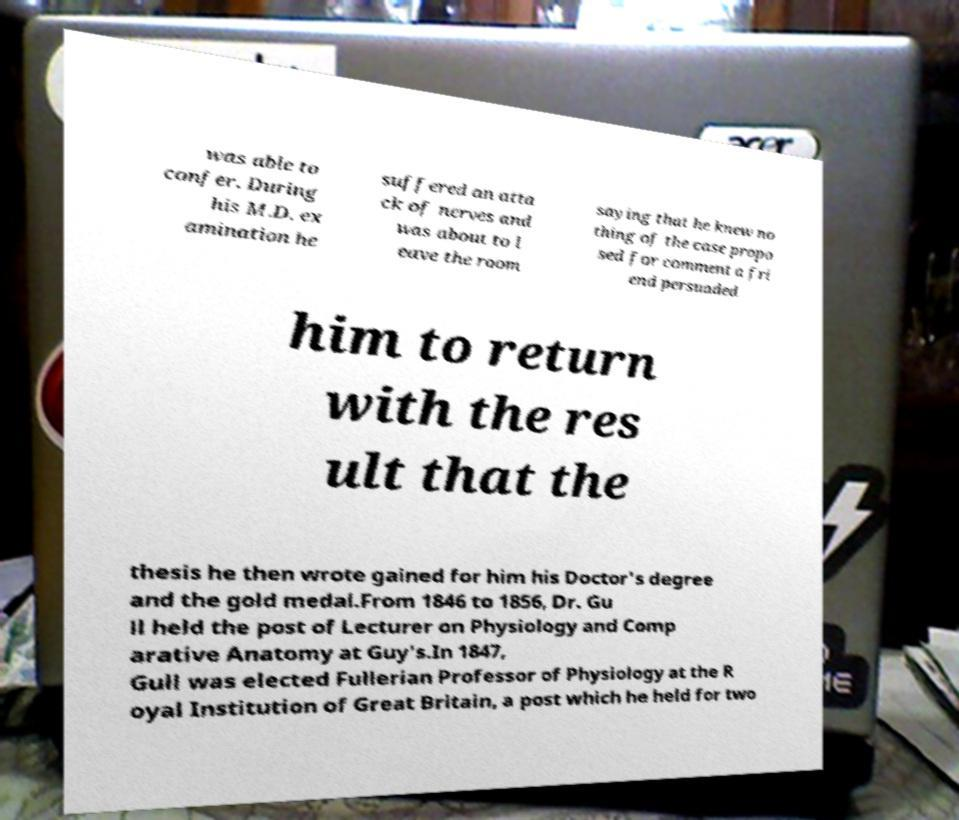Can you accurately transcribe the text from the provided image for me? was able to confer. During his M.D. ex amination he suffered an atta ck of nerves and was about to l eave the room saying that he knew no thing of the case propo sed for comment a fri end persuaded him to return with the res ult that the thesis he then wrote gained for him his Doctor's degree and the gold medal.From 1846 to 1856, Dr. Gu ll held the post of Lecturer on Physiology and Comp arative Anatomy at Guy's.In 1847, Gull was elected Fullerian Professor of Physiology at the R oyal Institution of Great Britain, a post which he held for two 